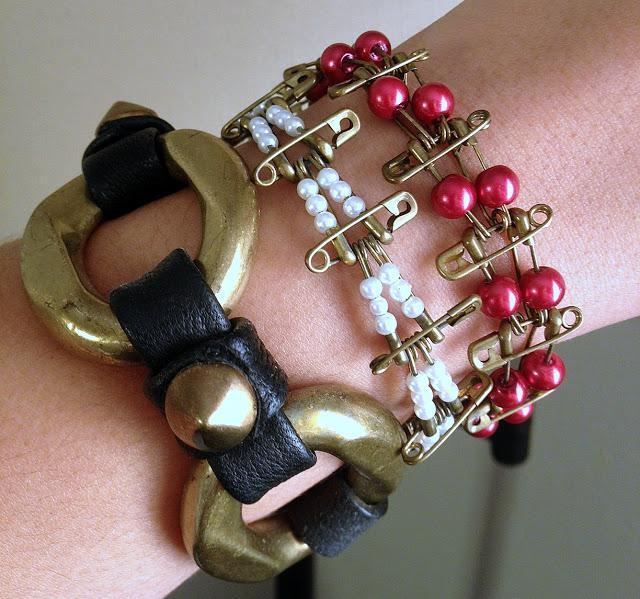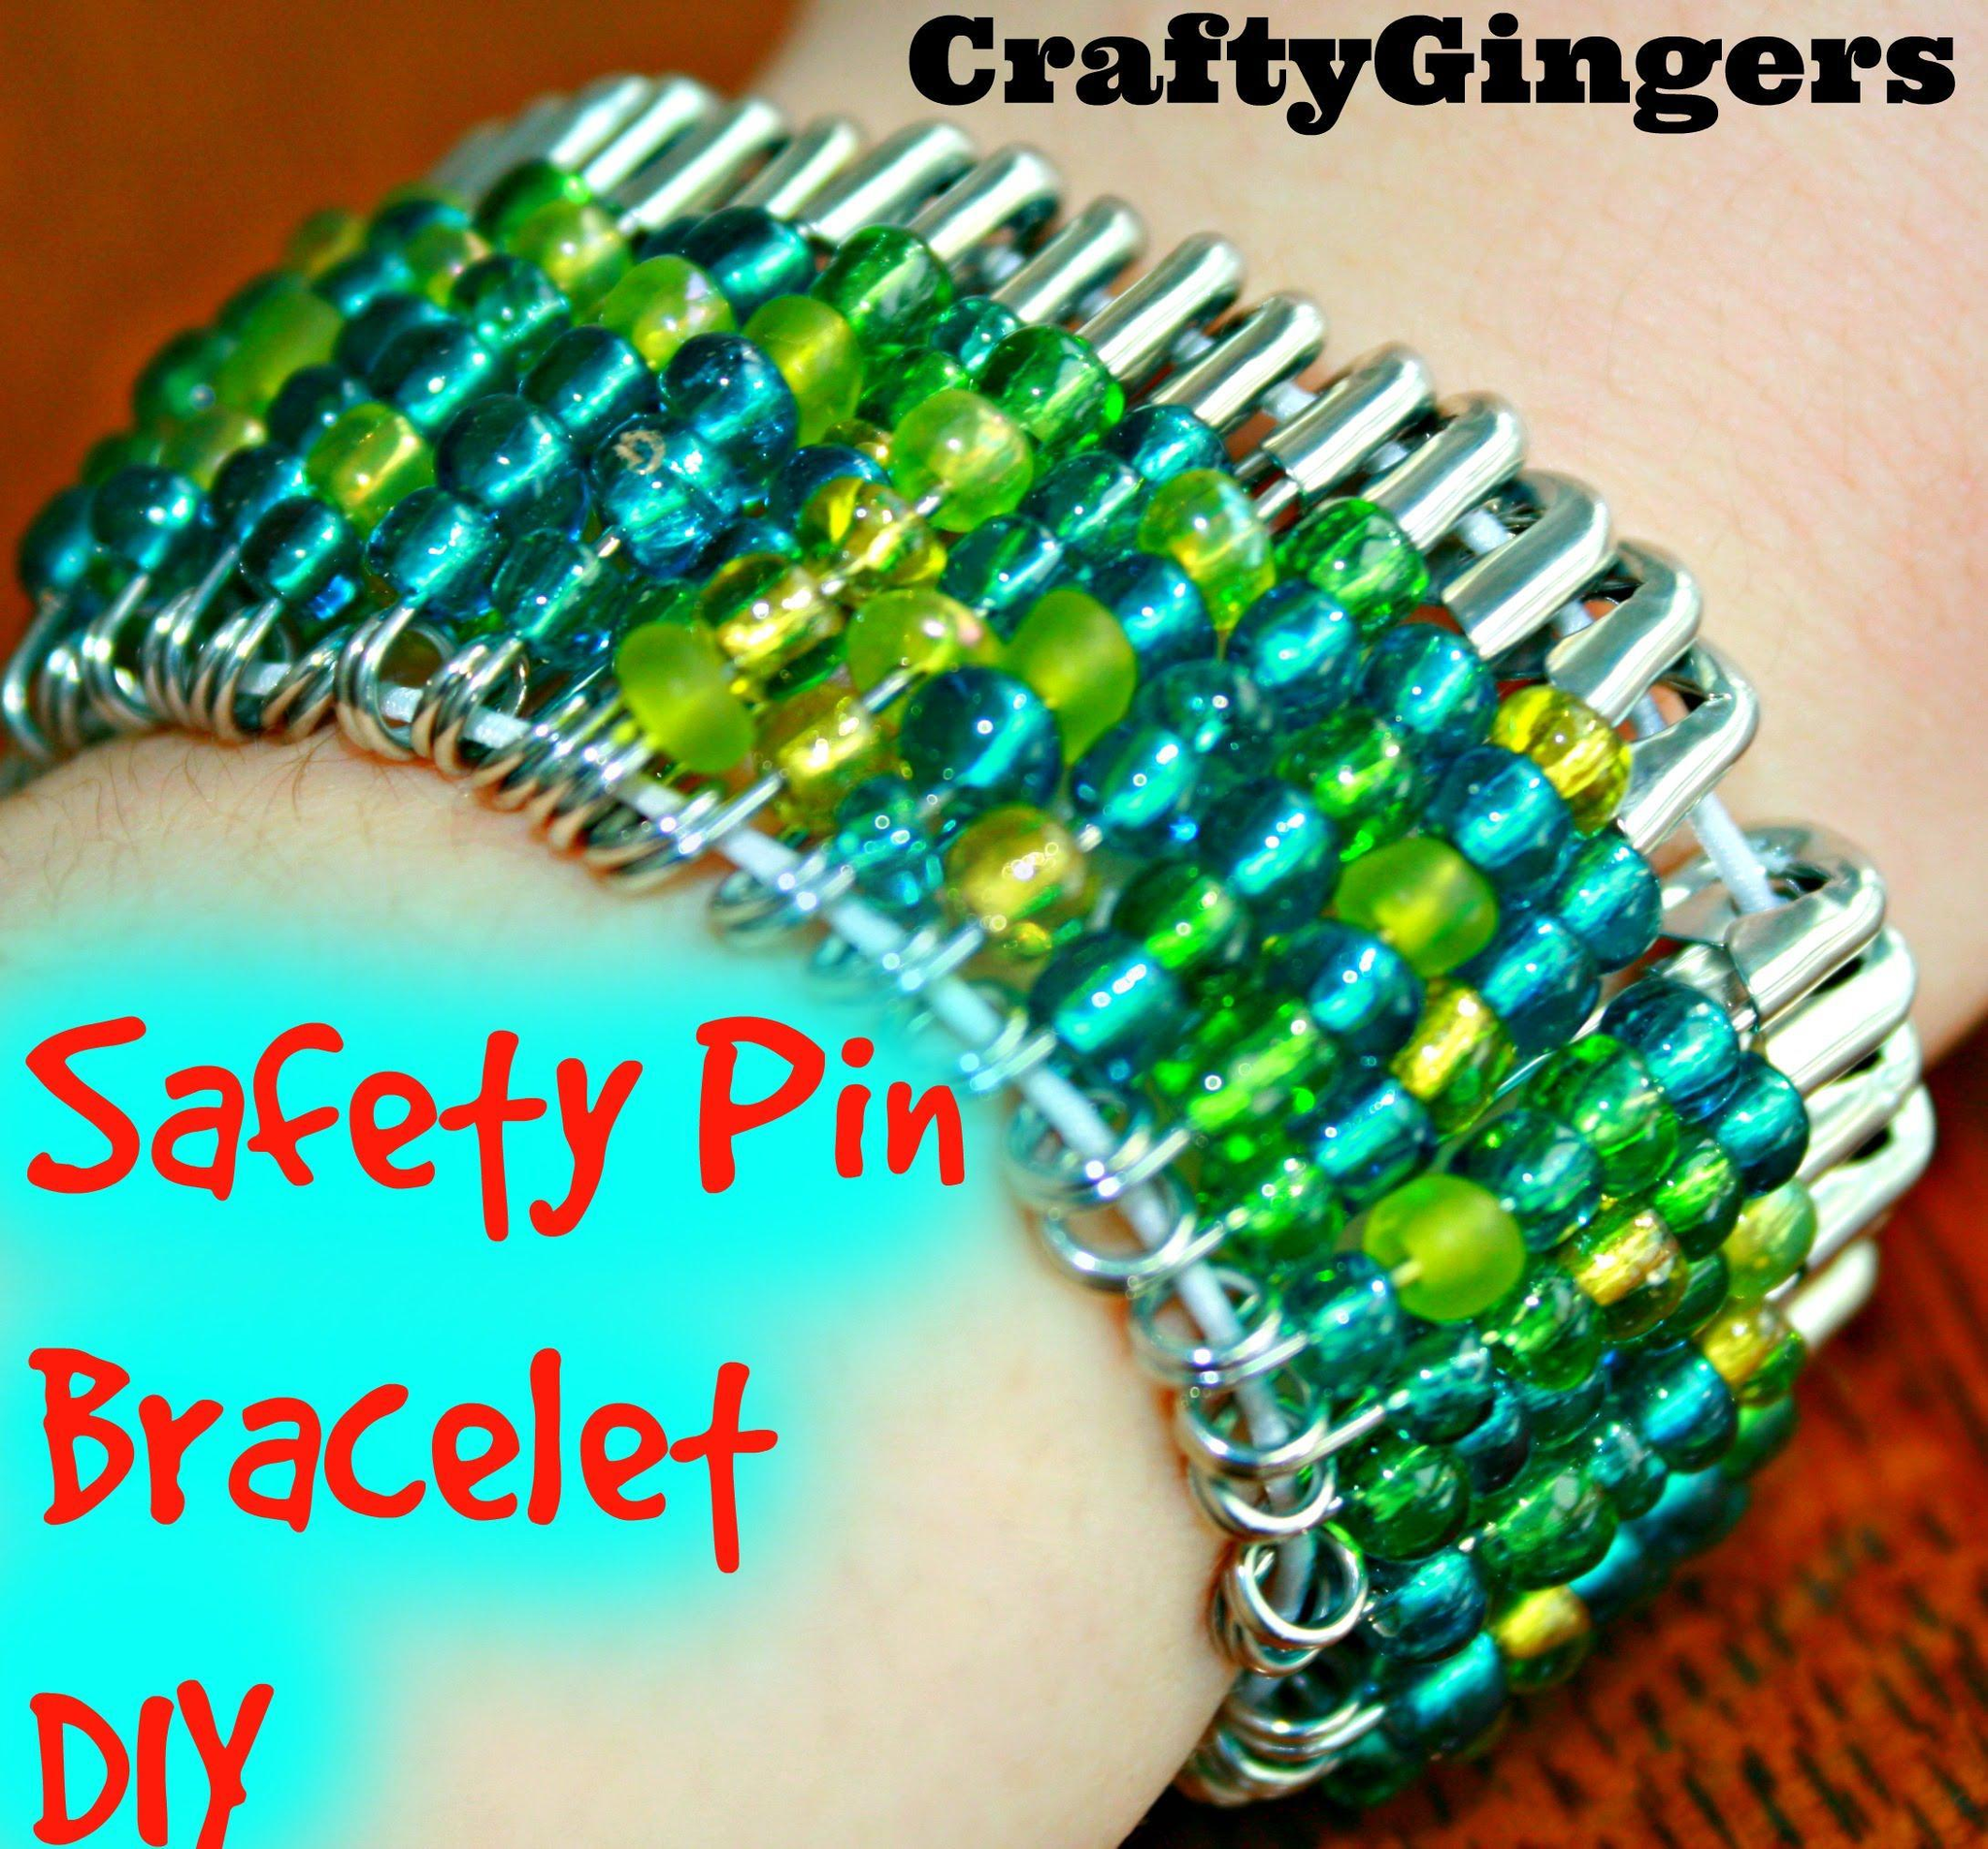The first image is the image on the left, the second image is the image on the right. Assess this claim about the two images: "The image on the right contains a bracelet with green beads on it.". Correct or not? Answer yes or no. Yes. The first image is the image on the left, the second image is the image on the right. For the images displayed, is the sentence "There are multiple pieces of jewelry on a woman’s arm that are not just gold colored." factually correct? Answer yes or no. Yes. 